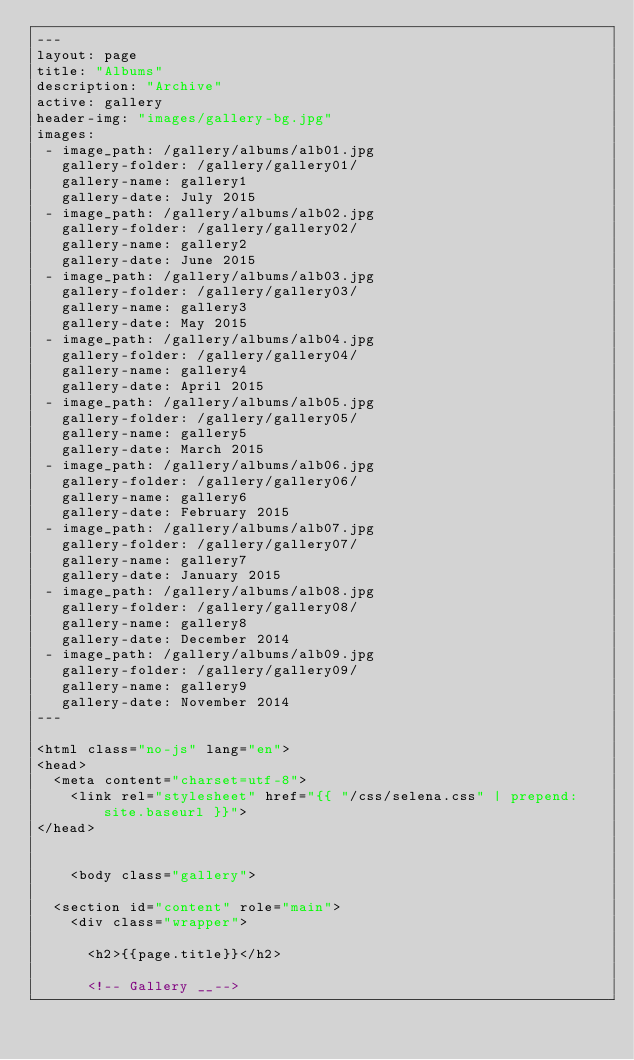<code> <loc_0><loc_0><loc_500><loc_500><_HTML_>---
layout: page
title: "Albums"
description: "Archive"
active: gallery
header-img: "images/gallery-bg.jpg"
images:
 - image_path: /gallery/albums/alb01.jpg
   gallery-folder: /gallery/gallery01/
   gallery-name: gallery1
   gallery-date: July 2015
 - image_path: /gallery/albums/alb02.jpg
   gallery-folder: /gallery/gallery02/
   gallery-name: gallery2
   gallery-date: June 2015
 - image_path: /gallery/albums/alb03.jpg
   gallery-folder: /gallery/gallery03/
   gallery-name: gallery3
   gallery-date: May 2015
 - image_path: /gallery/albums/alb04.jpg
   gallery-folder: /gallery/gallery04/
   gallery-name: gallery4
   gallery-date: April 2015
 - image_path: /gallery/albums/alb05.jpg
   gallery-folder: /gallery/gallery05/
   gallery-name: gallery5
   gallery-date: March 2015
 - image_path: /gallery/albums/alb06.jpg
   gallery-folder: /gallery/gallery06/
   gallery-name: gallery6
   gallery-date: February 2015
 - image_path: /gallery/albums/alb07.jpg
   gallery-folder: /gallery/gallery07/
   gallery-name: gallery7
   gallery-date: January 2015
 - image_path: /gallery/albums/alb08.jpg
   gallery-folder: /gallery/gallery08/
   gallery-name: gallery8
   gallery-date: December 2014
 - image_path: /gallery/albums/alb09.jpg
   gallery-folder: /gallery/gallery09/
   gallery-name: gallery9
   gallery-date: November 2014
---

<html class="no-js" lang="en">
<head>
	<meta content="charset=utf-8">
    <link rel="stylesheet" href="{{ "/css/selena.css" | prepend: site.baseurl }}">
</head>


    <body class="gallery">

	<section id="content" role="main">
		<div class="wrapper">

			<h2>{{page.title}}</h2>

			<!-- Gallery __--></code> 